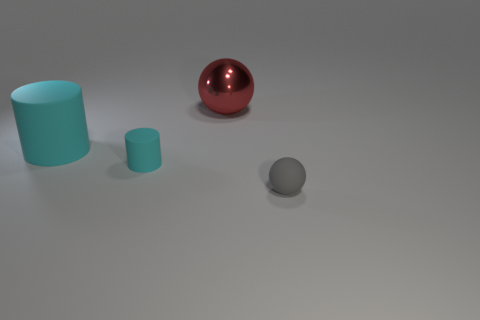What number of things are tiny shiny cylinders or large objects?
Your answer should be very brief. 2. What number of cylinders are to the left of the cyan object that is on the right side of the large cyan object left of the metallic object?
Give a very brief answer. 1. There is a red object that is the same shape as the gray thing; what is it made of?
Your answer should be very brief. Metal. What is the material of the object that is both in front of the red object and behind the tiny cyan matte object?
Offer a very short reply. Rubber. Are there fewer metallic balls left of the big metal object than cyan matte objects that are in front of the tiny matte cylinder?
Provide a short and direct response. No. What number of other things are the same size as the gray object?
Keep it short and to the point. 1. What shape is the matte object behind the cyan rubber cylinder that is in front of the large object to the left of the large metal object?
Provide a succinct answer. Cylinder. How many red objects are either large balls or big things?
Provide a short and direct response. 1. What number of tiny cyan matte cylinders are to the left of the matte object that is on the right side of the red ball?
Keep it short and to the point. 1. Is there any other thing that has the same color as the large rubber cylinder?
Provide a succinct answer. Yes. 